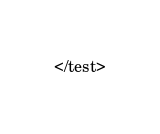Convert code to text. <code><loc_0><loc_0><loc_500><loc_500><_XML_></test>
</code> 